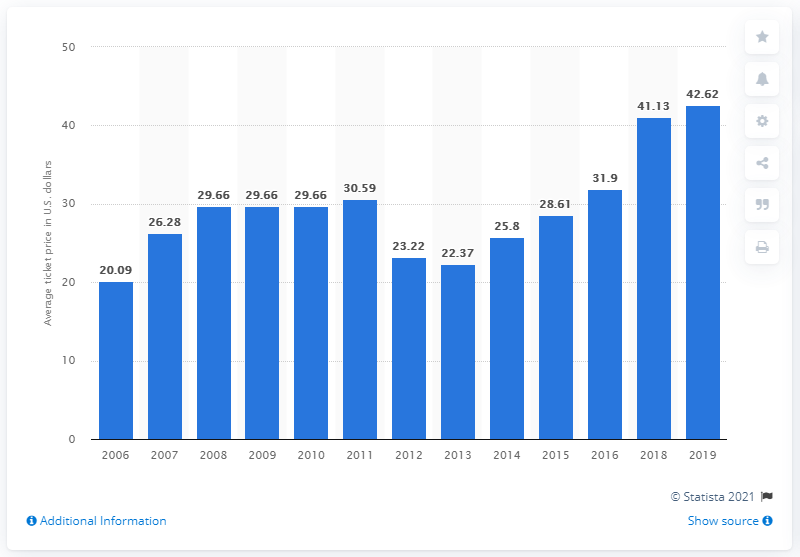Give some essential details in this illustration. According to data from 2019, the average ticket price for Los Angeles Dodgers games was approximately 42.62 dollars. 